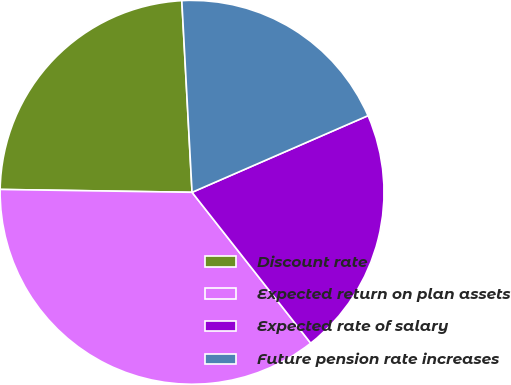Convert chart to OTSL. <chart><loc_0><loc_0><loc_500><loc_500><pie_chart><fcel>Discount rate<fcel>Expected return on plan assets<fcel>Expected rate of salary<fcel>Future pension rate increases<nl><fcel>23.91%<fcel>35.84%<fcel>20.93%<fcel>19.31%<nl></chart> 